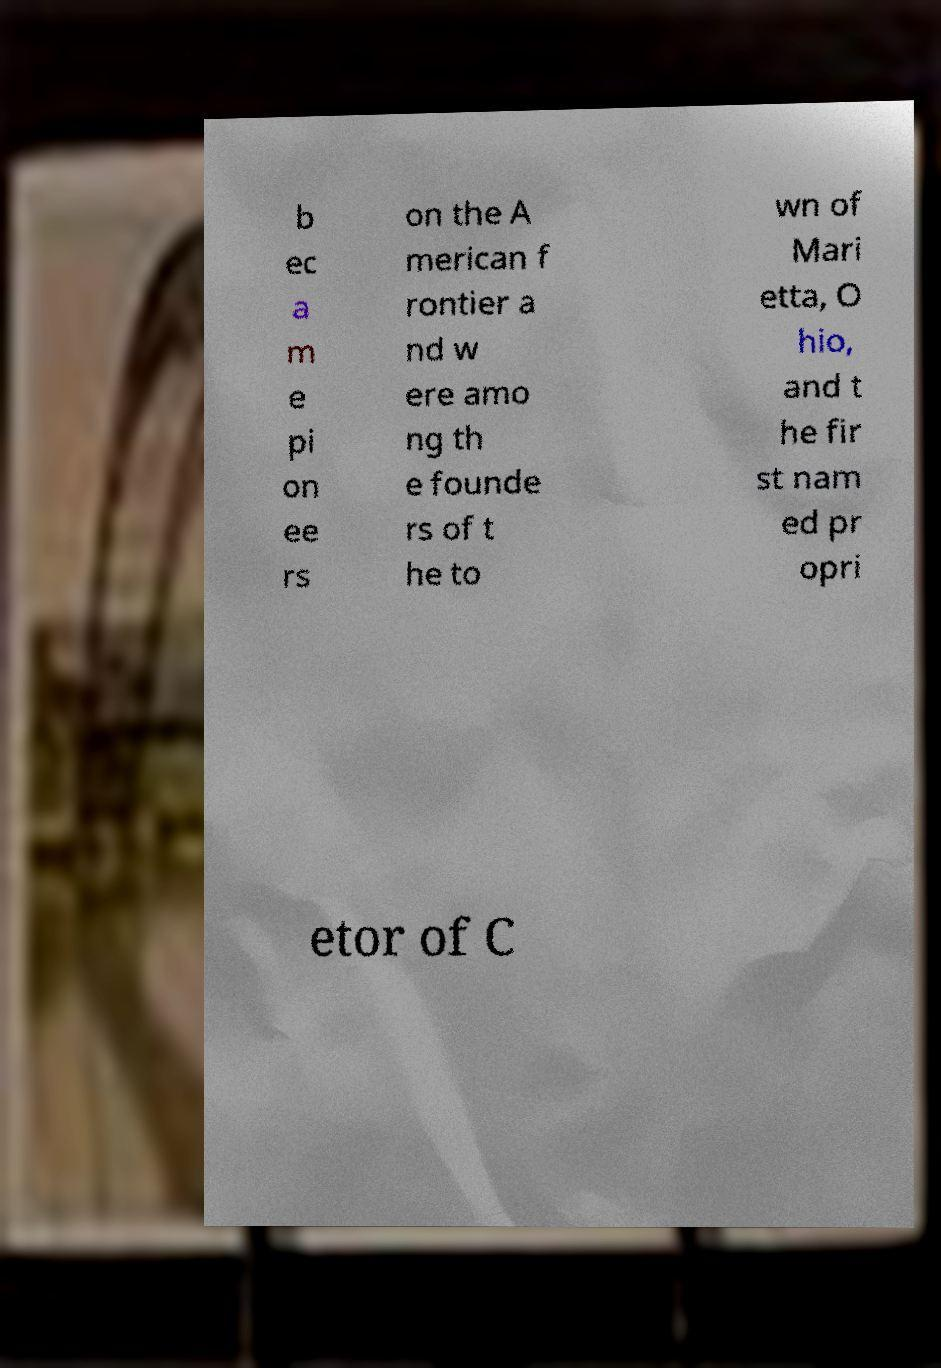There's text embedded in this image that I need extracted. Can you transcribe it verbatim? b ec a m e pi on ee rs on the A merican f rontier a nd w ere amo ng th e founde rs of t he to wn of Mari etta, O hio, and t he fir st nam ed pr opri etor of C 